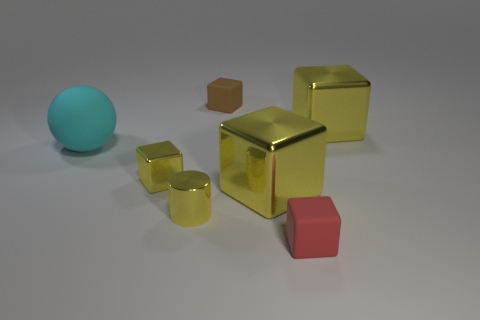There is a tiny cube to the left of the yellow shiny cylinder; does it have the same color as the shiny block that is behind the small shiny block?
Keep it short and to the point. Yes. What shape is the small object that is the same color as the metallic cylinder?
Provide a succinct answer. Cube. What number of objects are either tiny yellow blocks or cubes in front of the big cyan ball?
Offer a very short reply. 3. Are there any small yellow objects of the same shape as the small red thing?
Give a very brief answer. Yes. Are there an equal number of small red rubber objects left of the cylinder and yellow metal objects to the left of the brown matte cube?
Give a very brief answer. No. Is there anything else that has the same size as the red matte object?
Keep it short and to the point. Yes. How many green things are either large cubes or blocks?
Keep it short and to the point. 0. How many things are the same size as the red rubber block?
Give a very brief answer. 3. There is a shiny block that is both in front of the cyan matte sphere and to the right of the tiny brown cube; what is its color?
Your answer should be compact. Yellow. Is the number of big cyan matte balls that are behind the yellow metallic cylinder greater than the number of small cylinders?
Make the answer very short. No. 